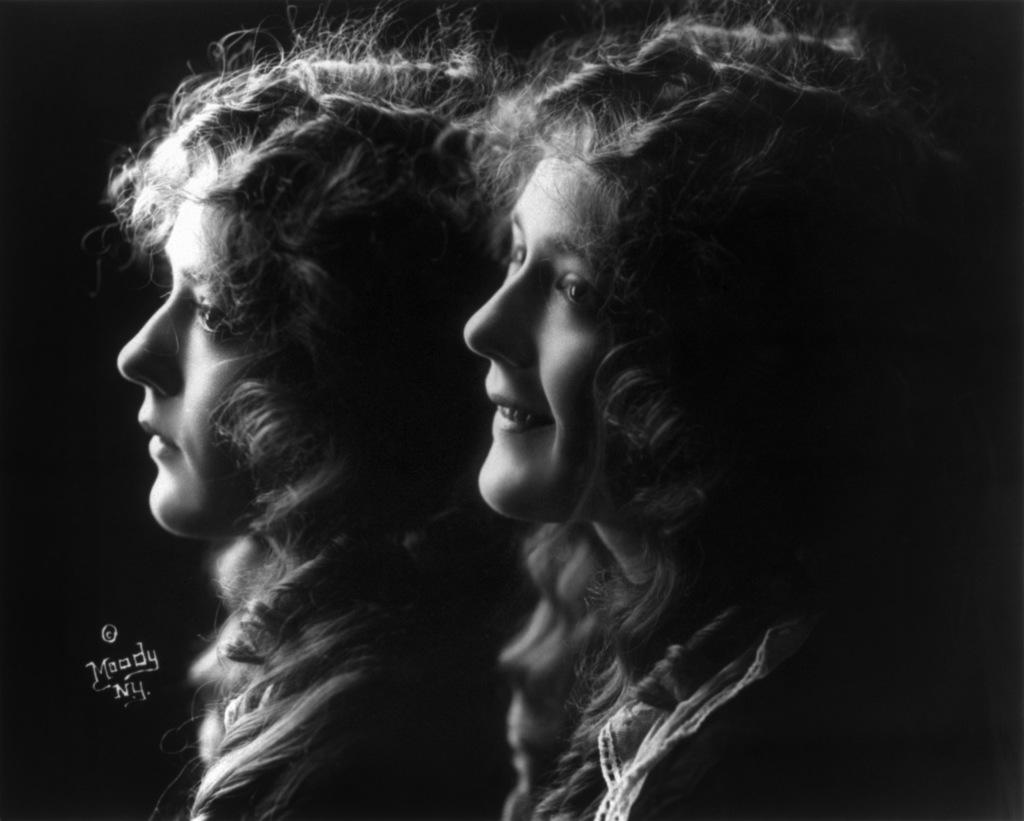How many people are in the image? There are two girls in the image. What can be seen in the background of the image? The background of the image is dark. What type of food is the ant carrying in the image? There is no ant or food present in the image. What type of work does the farmer do in the image? There is no farmer present in the image. 